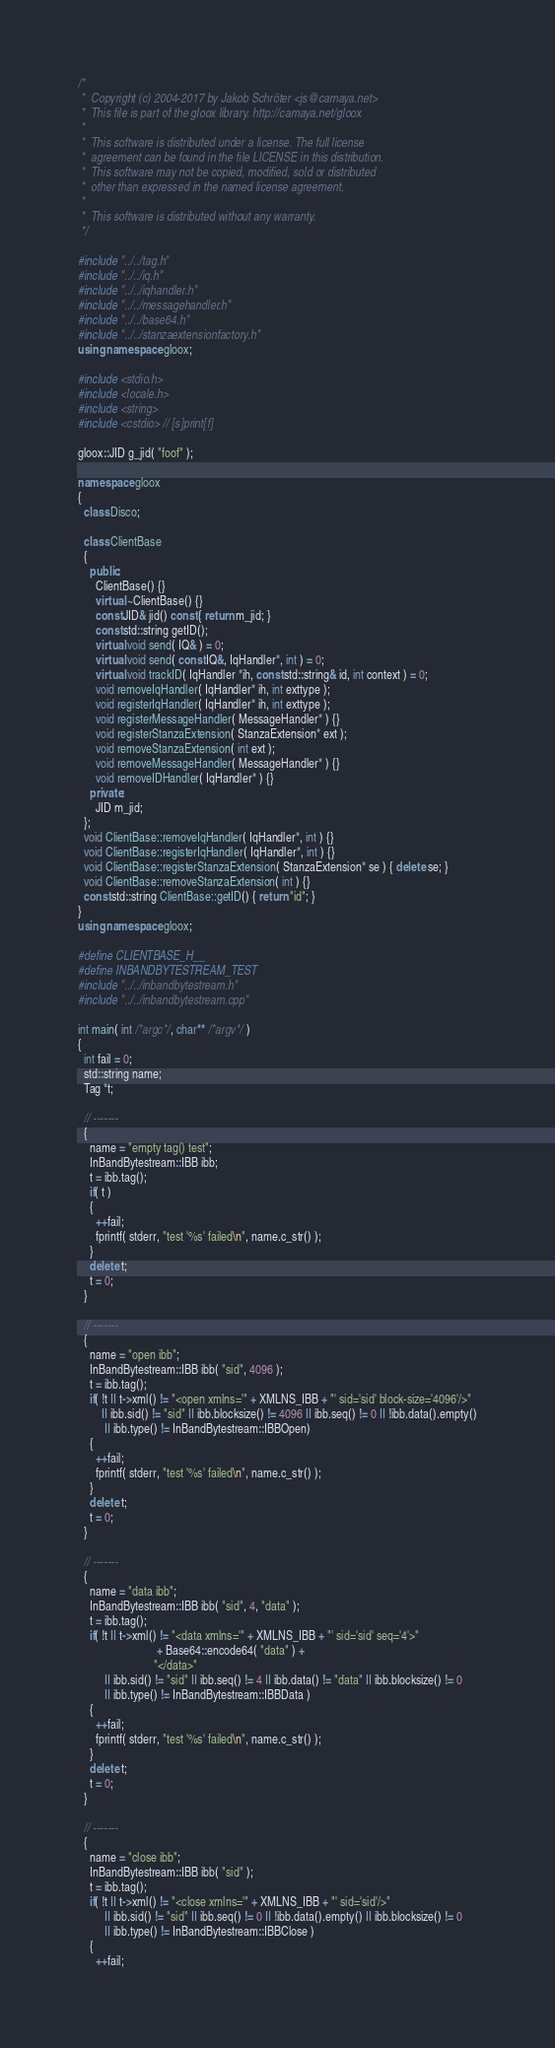<code> <loc_0><loc_0><loc_500><loc_500><_C++_>/*
 *  Copyright (c) 2004-2017 by Jakob Schröter <js@camaya.net>
 *  This file is part of the gloox library. http://camaya.net/gloox
 *
 *  This software is distributed under a license. The full license
 *  agreement can be found in the file LICENSE in this distribution.
 *  This software may not be copied, modified, sold or distributed
 *  other than expressed in the named license agreement.
 *
 *  This software is distributed without any warranty.
 */

#include "../../tag.h"
#include "../../iq.h"
#include "../../iqhandler.h"
#include "../../messagehandler.h"
#include "../../base64.h"
#include "../../stanzaextensionfactory.h"
using namespace gloox;

#include <stdio.h>
#include <locale.h>
#include <string>
#include <cstdio> // [s]print[f]

gloox::JID g_jid( "foof" );

namespace gloox
{
  class Disco;

  class ClientBase
  {
    public:
      ClientBase() {}
      virtual ~ClientBase() {}
      const JID& jid() const { return m_jid; }
      const std::string getID();
      virtual void send( IQ& ) = 0;
      virtual void send( const IQ&, IqHandler*, int ) = 0;
      virtual void trackID( IqHandler *ih, const std::string& id, int context ) = 0;
      void removeIqHandler( IqHandler* ih, int exttype );
      void registerIqHandler( IqHandler* ih, int exttype );
      void registerMessageHandler( MessageHandler* ) {}
      void registerStanzaExtension( StanzaExtension* ext );
      void removeStanzaExtension( int ext );
      void removeMessageHandler( MessageHandler* ) {}
      void removeIDHandler( IqHandler* ) {}
    private:
      JID m_jid;
  };
  void ClientBase::removeIqHandler( IqHandler*, int ) {}
  void ClientBase::registerIqHandler( IqHandler*, int ) {}
  void ClientBase::registerStanzaExtension( StanzaExtension* se ) { delete se; }
  void ClientBase::removeStanzaExtension( int ) {}
  const std::string ClientBase::getID() { return "id"; }
}
using namespace gloox;

#define CLIENTBASE_H__
#define INBANDBYTESTREAM_TEST
#include "../../inbandbytestream.h"
#include "../../inbandbytestream.cpp"

int main( int /*argc*/, char** /*argv*/ )
{
  int fail = 0;
  std::string name;
  Tag *t;

  // -------
  {
    name = "empty tag() test";
    InBandBytestream::IBB ibb;
    t = ibb.tag();
    if( t )
    {
      ++fail;
      fprintf( stderr, "test '%s' failed\n", name.c_str() );
    }
    delete t;
    t = 0;
  }

  // -------
  {
    name = "open ibb";
    InBandBytestream::IBB ibb( "sid", 4096 );
    t = ibb.tag();
    if( !t || t->xml() != "<open xmlns='" + XMLNS_IBB + "' sid='sid' block-size='4096'/>"
        || ibb.sid() != "sid" || ibb.blocksize() != 4096 || ibb.seq() != 0 || !ibb.data().empty()
         || ibb.type() != InBandBytestream::IBBOpen)
    {
      ++fail;
      fprintf( stderr, "test '%s' failed\n", name.c_str() );
    }
    delete t;
    t = 0;
  }

  // -------
  {
    name = "data ibb";
    InBandBytestream::IBB ibb( "sid", 4, "data" );
    t = ibb.tag();
    if( !t || t->xml() != "<data xmlns='" + XMLNS_IBB + "' sid='sid' seq='4'>"
                           + Base64::encode64( "data" ) +
                          "</data>"
         || ibb.sid() != "sid" || ibb.seq() != 4 || ibb.data() != "data" || ibb.blocksize() != 0
         || ibb.type() != InBandBytestream::IBBData )
    {
      ++fail;
      fprintf( stderr, "test '%s' failed\n", name.c_str() );
    }
    delete t;
    t = 0;
  }

  // -------
  {
    name = "close ibb";
    InBandBytestream::IBB ibb( "sid" );
    t = ibb.tag();
    if( !t || t->xml() != "<close xmlns='" + XMLNS_IBB + "' sid='sid'/>"
         || ibb.sid() != "sid" || ibb.seq() != 0 || !ibb.data().empty() || ibb.blocksize() != 0
         || ibb.type() != InBandBytestream::IBBClose )
    {
      ++fail;</code> 